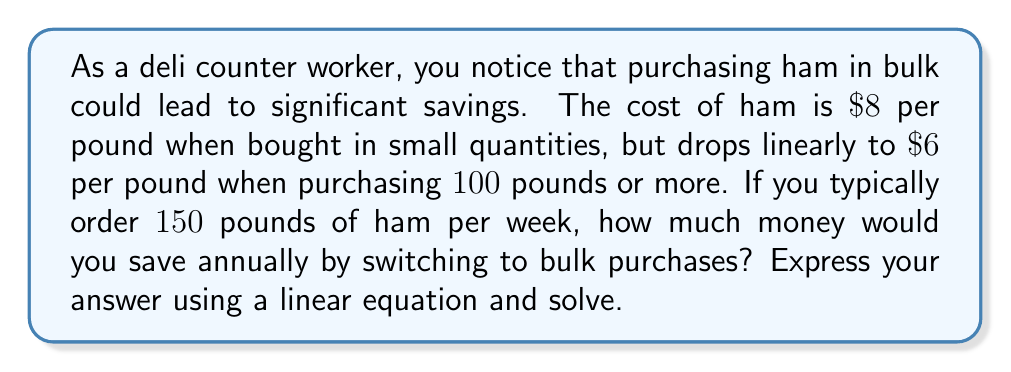Teach me how to tackle this problem. Let's approach this step-by-step:

1) First, we need to establish our linear equation. Let $x$ be the number of pounds and $y$ be the price per pound.

2) We know two points on this line:
   $(0, 8)$ and $(100, 6)$

3) We can use the point-slope form of a linear equation:
   $y - y_1 = m(x - x_1)$

4) Calculate the slope $m$:
   $m = \frac{y_2 - y_1}{x_2 - x_1} = \frac{6 - 8}{100 - 0} = -\frac{1}{50}$

5) Our equation becomes:
   $y - 8 = -\frac{1}{50}(x - 0)$

6) Simplify:
   $y = -\frac{1}{50}x + 8$

7) Now, we can calculate the price per pound for 150 pounds:
   $y = -\frac{1}{50}(150) + 8 = 5$

8) So, the bulk price is $\$5$ per pound.

9) Calculate annual savings:
   - Without bulk: $150 \times 52 \times \$8 = \$62,400$
   - With bulk: $150 \times 52 \times \$5 = \$39,000$
   - Annual savings: $\$62,400 - \$39,000 = \$23,400$
Answer: $\$23,400$ 